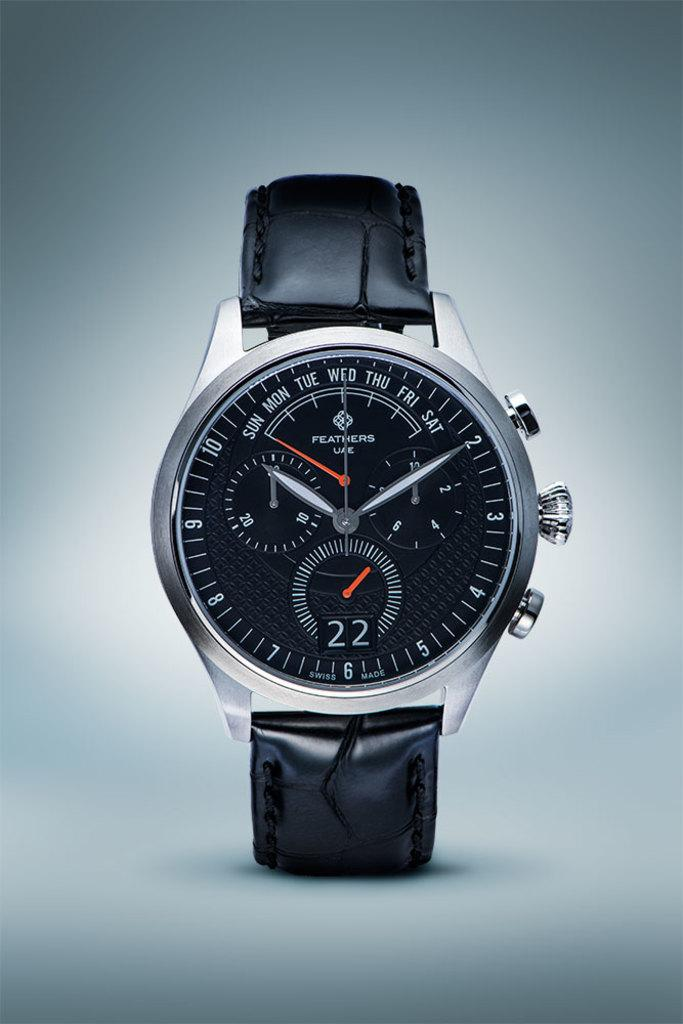Provide a one-sentence caption for the provided image. A silver and black watch with the digit 22 on the face. 